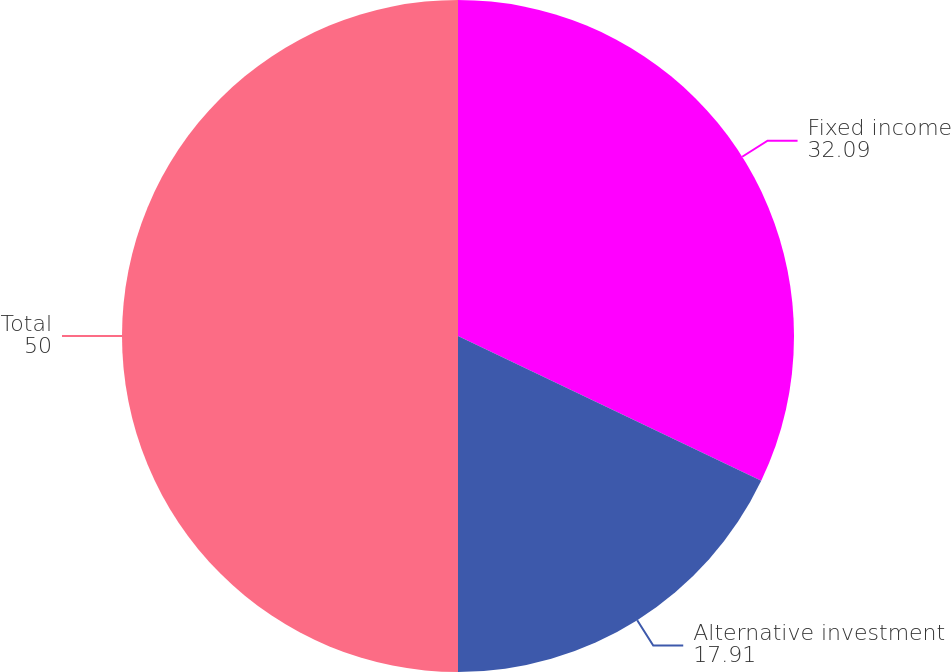Convert chart. <chart><loc_0><loc_0><loc_500><loc_500><pie_chart><fcel>Fixed income<fcel>Alternative investment<fcel>Total<nl><fcel>32.09%<fcel>17.91%<fcel>50.0%<nl></chart> 